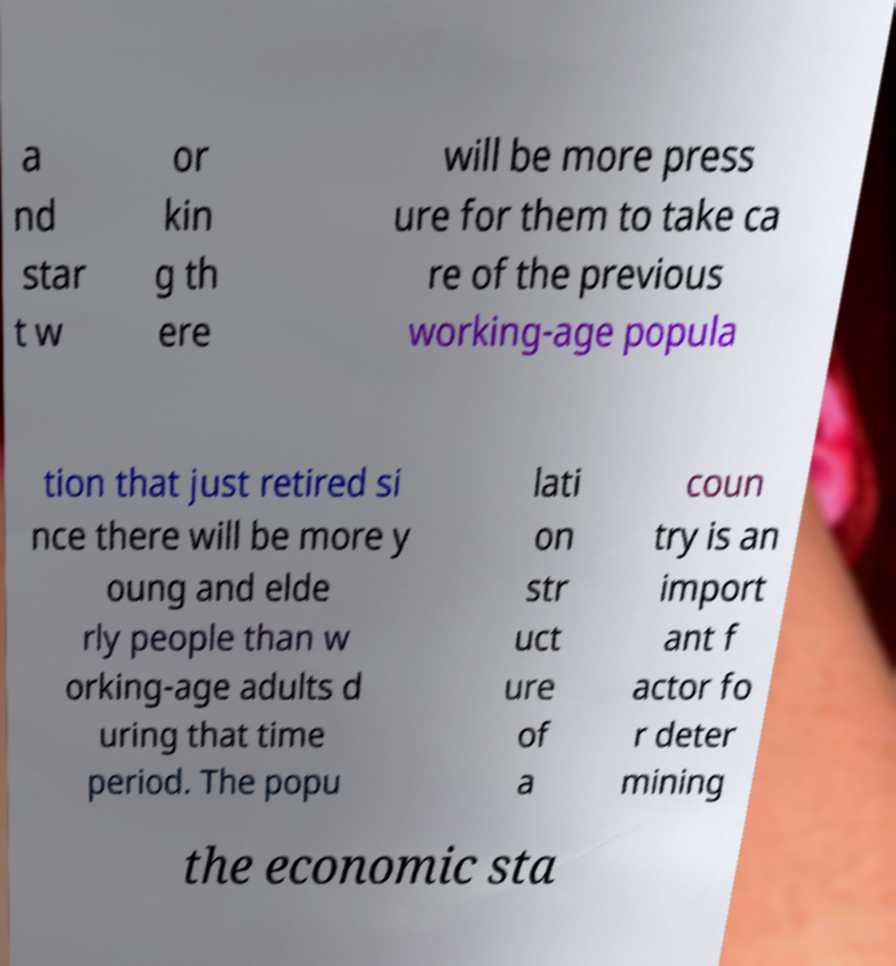I need the written content from this picture converted into text. Can you do that? a nd star t w or kin g th ere will be more press ure for them to take ca re of the previous working-age popula tion that just retired si nce there will be more y oung and elde rly people than w orking-age adults d uring that time period. The popu lati on str uct ure of a coun try is an import ant f actor fo r deter mining the economic sta 